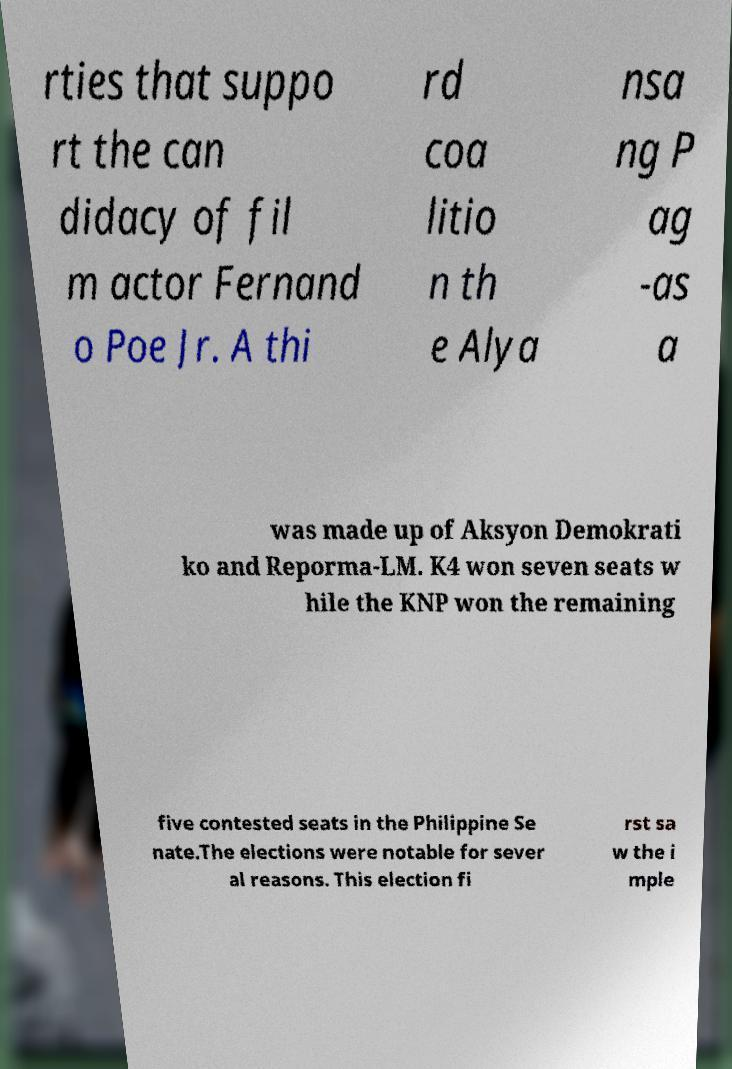I need the written content from this picture converted into text. Can you do that? rties that suppo rt the can didacy of fil m actor Fernand o Poe Jr. A thi rd coa litio n th e Alya nsa ng P ag -as a was made up of Aksyon Demokrati ko and Reporma-LM. K4 won seven seats w hile the KNP won the remaining five contested seats in the Philippine Se nate.The elections were notable for sever al reasons. This election fi rst sa w the i mple 